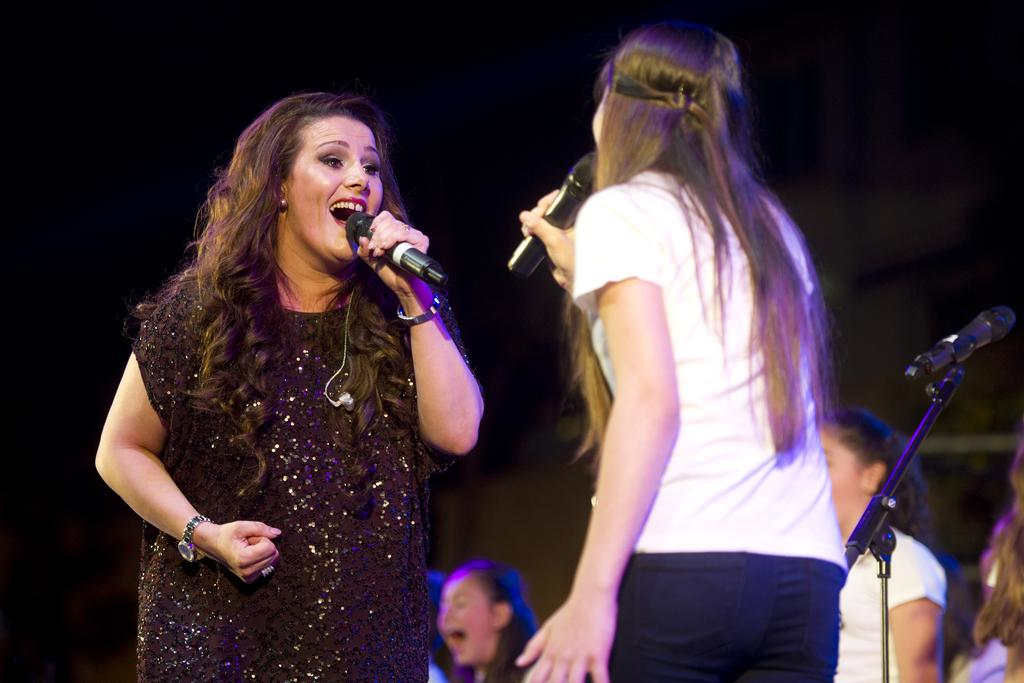How many people are in the image? There are two women in the image. What are the women doing in the image? The women are singing. What object might be used to amplify their voices? A microphone is present in the image. What type of structure can be seen in the background of the image? There is no structure visible in the background of the image. How many apples are being held by the women in the image? There are no apples present in the image. 